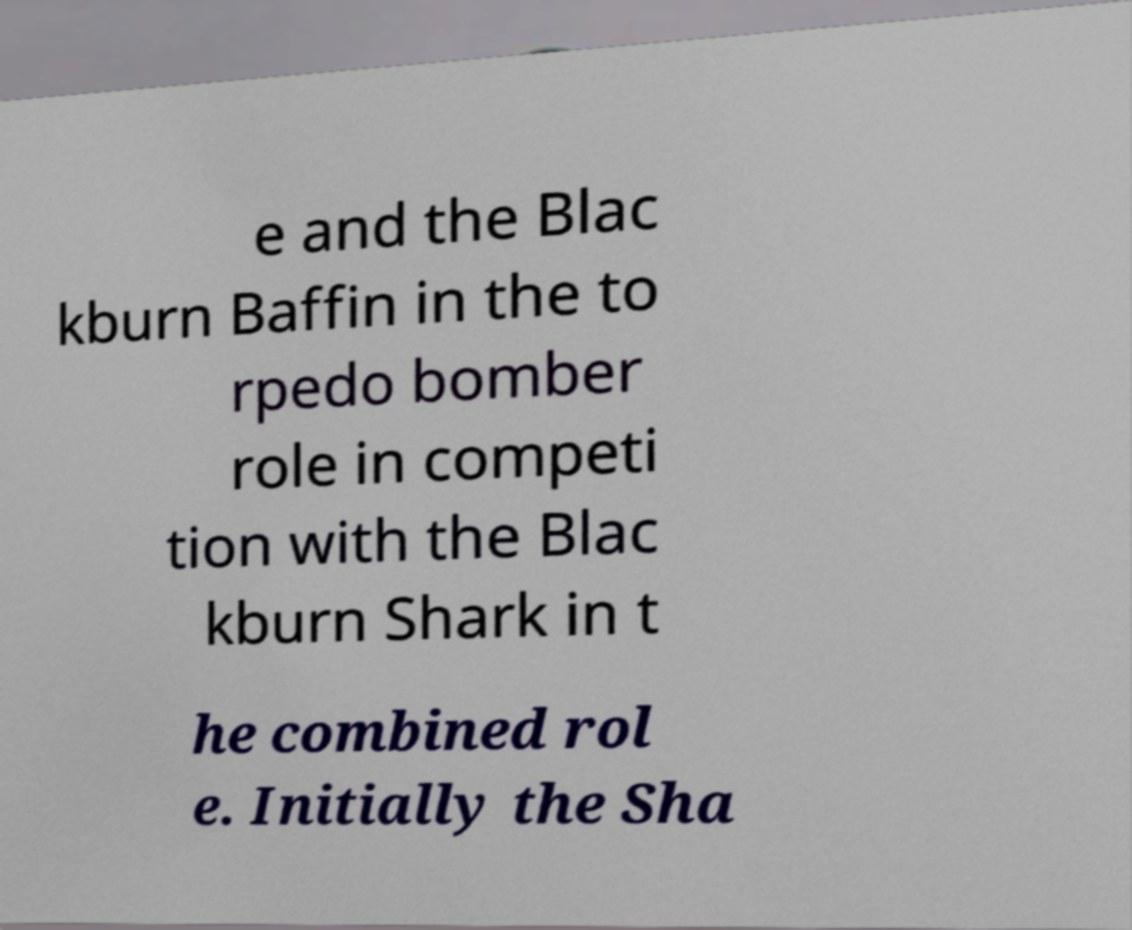Can you read and provide the text displayed in the image?This photo seems to have some interesting text. Can you extract and type it out for me? e and the Blac kburn Baffin in the to rpedo bomber role in competi tion with the Blac kburn Shark in t he combined rol e. Initially the Sha 